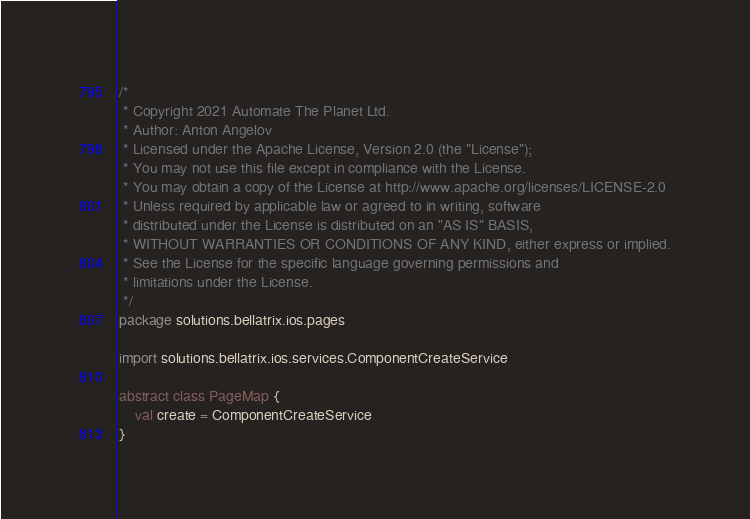Convert code to text. <code><loc_0><loc_0><loc_500><loc_500><_Kotlin_>/*
 * Copyright 2021 Automate The Planet Ltd.
 * Author: Anton Angelov
 * Licensed under the Apache License, Version 2.0 (the "License");
 * You may not use this file except in compliance with the License.
 * You may obtain a copy of the License at http://www.apache.org/licenses/LICENSE-2.0
 * Unless required by applicable law or agreed to in writing, software
 * distributed under the License is distributed on an "AS IS" BASIS,
 * WITHOUT WARRANTIES OR CONDITIONS OF ANY KIND, either express or implied.
 * See the License for the specific language governing permissions and
 * limitations under the License.
 */
package solutions.bellatrix.ios.pages

import solutions.bellatrix.ios.services.ComponentCreateService

abstract class PageMap {
    val create = ComponentCreateService
}</code> 